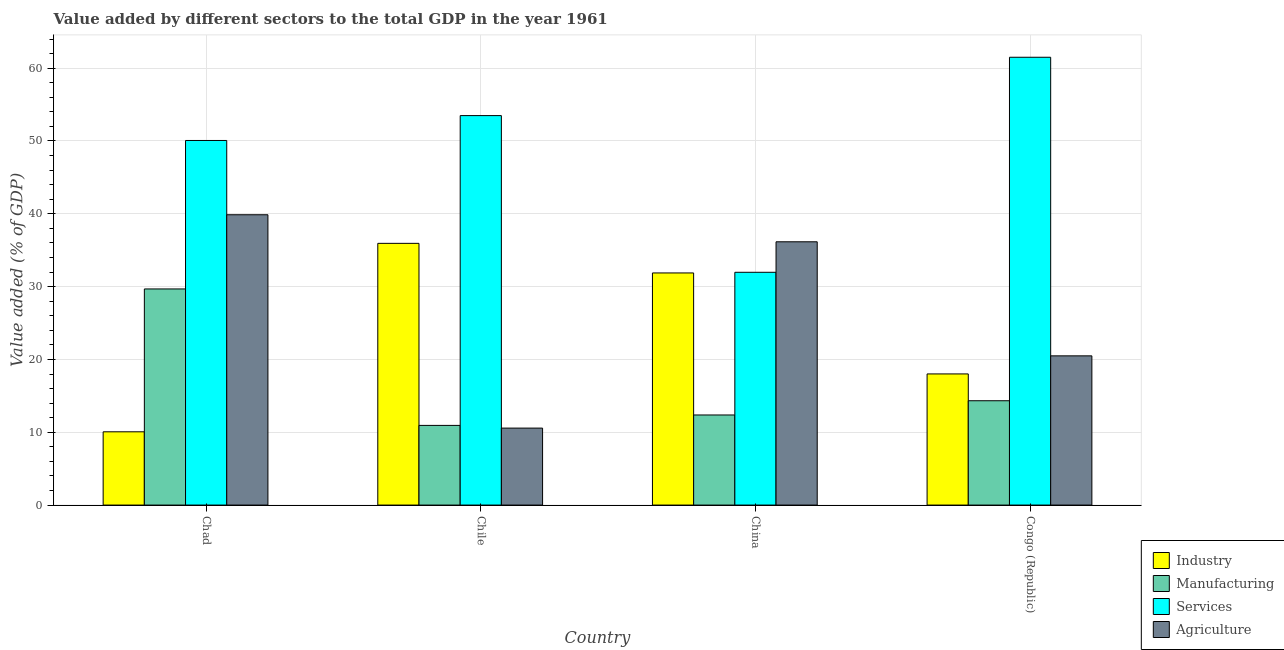How many different coloured bars are there?
Make the answer very short. 4. How many groups of bars are there?
Offer a terse response. 4. Are the number of bars on each tick of the X-axis equal?
Give a very brief answer. Yes. What is the label of the 1st group of bars from the left?
Your response must be concise. Chad. What is the value added by industrial sector in Congo (Republic)?
Ensure brevity in your answer.  18.01. Across all countries, what is the maximum value added by manufacturing sector?
Your answer should be very brief. 29.68. Across all countries, what is the minimum value added by agricultural sector?
Keep it short and to the point. 10.57. In which country was the value added by agricultural sector maximum?
Your answer should be very brief. Chad. In which country was the value added by industrial sector minimum?
Ensure brevity in your answer.  Chad. What is the total value added by industrial sector in the graph?
Your response must be concise. 95.89. What is the difference between the value added by industrial sector in Chile and that in Congo (Republic)?
Keep it short and to the point. 17.93. What is the difference between the value added by industrial sector in China and the value added by agricultural sector in Chad?
Your response must be concise. -7.99. What is the average value added by manufacturing sector per country?
Provide a short and direct response. 16.83. What is the difference between the value added by agricultural sector and value added by manufacturing sector in Congo (Republic)?
Your answer should be compact. 6.16. In how many countries, is the value added by industrial sector greater than 28 %?
Offer a very short reply. 2. What is the ratio of the value added by manufacturing sector in Chile to that in China?
Offer a very short reply. 0.88. Is the value added by services sector in Chad less than that in Congo (Republic)?
Make the answer very short. Yes. What is the difference between the highest and the second highest value added by manufacturing sector?
Provide a succinct answer. 15.35. What is the difference between the highest and the lowest value added by industrial sector?
Give a very brief answer. 25.88. In how many countries, is the value added by industrial sector greater than the average value added by industrial sector taken over all countries?
Offer a very short reply. 2. What does the 2nd bar from the left in China represents?
Your answer should be compact. Manufacturing. What does the 2nd bar from the right in Congo (Republic) represents?
Provide a succinct answer. Services. Is it the case that in every country, the sum of the value added by industrial sector and value added by manufacturing sector is greater than the value added by services sector?
Your answer should be very brief. No. How many bars are there?
Offer a very short reply. 16. Are all the bars in the graph horizontal?
Ensure brevity in your answer.  No. What is the difference between two consecutive major ticks on the Y-axis?
Give a very brief answer. 10. Are the values on the major ticks of Y-axis written in scientific E-notation?
Offer a terse response. No. Does the graph contain grids?
Keep it short and to the point. Yes. Where does the legend appear in the graph?
Your answer should be compact. Bottom right. How many legend labels are there?
Keep it short and to the point. 4. What is the title of the graph?
Provide a short and direct response. Value added by different sectors to the total GDP in the year 1961. What is the label or title of the Y-axis?
Ensure brevity in your answer.  Value added (% of GDP). What is the Value added (% of GDP) in Industry in Chad?
Your response must be concise. 10.06. What is the Value added (% of GDP) of Manufacturing in Chad?
Provide a succinct answer. 29.68. What is the Value added (% of GDP) in Services in Chad?
Give a very brief answer. 50.07. What is the Value added (% of GDP) in Agriculture in Chad?
Keep it short and to the point. 39.87. What is the Value added (% of GDP) of Industry in Chile?
Make the answer very short. 35.94. What is the Value added (% of GDP) in Manufacturing in Chile?
Provide a short and direct response. 10.94. What is the Value added (% of GDP) in Services in Chile?
Provide a short and direct response. 53.49. What is the Value added (% of GDP) in Agriculture in Chile?
Ensure brevity in your answer.  10.57. What is the Value added (% of GDP) in Industry in China?
Ensure brevity in your answer.  31.88. What is the Value added (% of GDP) of Manufacturing in China?
Your response must be concise. 12.37. What is the Value added (% of GDP) of Services in China?
Keep it short and to the point. 31.97. What is the Value added (% of GDP) of Agriculture in China?
Give a very brief answer. 36.16. What is the Value added (% of GDP) in Industry in Congo (Republic)?
Provide a short and direct response. 18.01. What is the Value added (% of GDP) in Manufacturing in Congo (Republic)?
Your answer should be very brief. 14.33. What is the Value added (% of GDP) of Services in Congo (Republic)?
Offer a terse response. 61.5. What is the Value added (% of GDP) in Agriculture in Congo (Republic)?
Provide a succinct answer. 20.49. Across all countries, what is the maximum Value added (% of GDP) of Industry?
Your answer should be very brief. 35.94. Across all countries, what is the maximum Value added (% of GDP) of Manufacturing?
Your answer should be very brief. 29.68. Across all countries, what is the maximum Value added (% of GDP) of Services?
Provide a succinct answer. 61.5. Across all countries, what is the maximum Value added (% of GDP) in Agriculture?
Make the answer very short. 39.87. Across all countries, what is the minimum Value added (% of GDP) in Industry?
Your response must be concise. 10.06. Across all countries, what is the minimum Value added (% of GDP) of Manufacturing?
Offer a very short reply. 10.94. Across all countries, what is the minimum Value added (% of GDP) of Services?
Give a very brief answer. 31.97. Across all countries, what is the minimum Value added (% of GDP) in Agriculture?
Ensure brevity in your answer.  10.57. What is the total Value added (% of GDP) in Industry in the graph?
Provide a short and direct response. 95.89. What is the total Value added (% of GDP) in Manufacturing in the graph?
Provide a succinct answer. 67.32. What is the total Value added (% of GDP) in Services in the graph?
Your answer should be very brief. 197.02. What is the total Value added (% of GDP) of Agriculture in the graph?
Give a very brief answer. 107.09. What is the difference between the Value added (% of GDP) in Industry in Chad and that in Chile?
Make the answer very short. -25.88. What is the difference between the Value added (% of GDP) in Manufacturing in Chad and that in Chile?
Ensure brevity in your answer.  18.74. What is the difference between the Value added (% of GDP) in Services in Chad and that in Chile?
Keep it short and to the point. -3.42. What is the difference between the Value added (% of GDP) in Agriculture in Chad and that in Chile?
Provide a succinct answer. 29.3. What is the difference between the Value added (% of GDP) in Industry in Chad and that in China?
Provide a succinct answer. -21.81. What is the difference between the Value added (% of GDP) of Manufacturing in Chad and that in China?
Your answer should be compact. 17.31. What is the difference between the Value added (% of GDP) of Services in Chad and that in China?
Your answer should be compact. 18.1. What is the difference between the Value added (% of GDP) of Agriculture in Chad and that in China?
Your answer should be very brief. 3.71. What is the difference between the Value added (% of GDP) of Industry in Chad and that in Congo (Republic)?
Your answer should be very brief. -7.95. What is the difference between the Value added (% of GDP) in Manufacturing in Chad and that in Congo (Republic)?
Ensure brevity in your answer.  15.35. What is the difference between the Value added (% of GDP) in Services in Chad and that in Congo (Republic)?
Provide a short and direct response. -11.43. What is the difference between the Value added (% of GDP) of Agriculture in Chad and that in Congo (Republic)?
Offer a very short reply. 19.38. What is the difference between the Value added (% of GDP) of Industry in Chile and that in China?
Give a very brief answer. 4.07. What is the difference between the Value added (% of GDP) of Manufacturing in Chile and that in China?
Your response must be concise. -1.43. What is the difference between the Value added (% of GDP) of Services in Chile and that in China?
Keep it short and to the point. 21.52. What is the difference between the Value added (% of GDP) of Agriculture in Chile and that in China?
Ensure brevity in your answer.  -25.58. What is the difference between the Value added (% of GDP) in Industry in Chile and that in Congo (Republic)?
Your response must be concise. 17.93. What is the difference between the Value added (% of GDP) of Manufacturing in Chile and that in Congo (Republic)?
Your response must be concise. -3.39. What is the difference between the Value added (% of GDP) in Services in Chile and that in Congo (Republic)?
Provide a succinct answer. -8.01. What is the difference between the Value added (% of GDP) in Agriculture in Chile and that in Congo (Republic)?
Offer a terse response. -9.92. What is the difference between the Value added (% of GDP) of Industry in China and that in Congo (Republic)?
Offer a very short reply. 13.87. What is the difference between the Value added (% of GDP) in Manufacturing in China and that in Congo (Republic)?
Keep it short and to the point. -1.96. What is the difference between the Value added (% of GDP) in Services in China and that in Congo (Republic)?
Offer a very short reply. -29.53. What is the difference between the Value added (% of GDP) of Agriculture in China and that in Congo (Republic)?
Give a very brief answer. 15.66. What is the difference between the Value added (% of GDP) in Industry in Chad and the Value added (% of GDP) in Manufacturing in Chile?
Offer a very short reply. -0.88. What is the difference between the Value added (% of GDP) in Industry in Chad and the Value added (% of GDP) in Services in Chile?
Offer a very short reply. -43.42. What is the difference between the Value added (% of GDP) of Industry in Chad and the Value added (% of GDP) of Agriculture in Chile?
Keep it short and to the point. -0.51. What is the difference between the Value added (% of GDP) of Manufacturing in Chad and the Value added (% of GDP) of Services in Chile?
Offer a terse response. -23.81. What is the difference between the Value added (% of GDP) in Manufacturing in Chad and the Value added (% of GDP) in Agriculture in Chile?
Your answer should be compact. 19.11. What is the difference between the Value added (% of GDP) of Services in Chad and the Value added (% of GDP) of Agriculture in Chile?
Provide a succinct answer. 39.5. What is the difference between the Value added (% of GDP) of Industry in Chad and the Value added (% of GDP) of Manufacturing in China?
Your answer should be very brief. -2.31. What is the difference between the Value added (% of GDP) of Industry in Chad and the Value added (% of GDP) of Services in China?
Ensure brevity in your answer.  -21.9. What is the difference between the Value added (% of GDP) of Industry in Chad and the Value added (% of GDP) of Agriculture in China?
Keep it short and to the point. -26.09. What is the difference between the Value added (% of GDP) in Manufacturing in Chad and the Value added (% of GDP) in Services in China?
Make the answer very short. -2.29. What is the difference between the Value added (% of GDP) in Manufacturing in Chad and the Value added (% of GDP) in Agriculture in China?
Keep it short and to the point. -6.48. What is the difference between the Value added (% of GDP) in Services in Chad and the Value added (% of GDP) in Agriculture in China?
Offer a terse response. 13.91. What is the difference between the Value added (% of GDP) in Industry in Chad and the Value added (% of GDP) in Manufacturing in Congo (Republic)?
Offer a terse response. -4.27. What is the difference between the Value added (% of GDP) of Industry in Chad and the Value added (% of GDP) of Services in Congo (Republic)?
Ensure brevity in your answer.  -51.44. What is the difference between the Value added (% of GDP) in Industry in Chad and the Value added (% of GDP) in Agriculture in Congo (Republic)?
Keep it short and to the point. -10.43. What is the difference between the Value added (% of GDP) in Manufacturing in Chad and the Value added (% of GDP) in Services in Congo (Republic)?
Your answer should be very brief. -31.82. What is the difference between the Value added (% of GDP) of Manufacturing in Chad and the Value added (% of GDP) of Agriculture in Congo (Republic)?
Offer a terse response. 9.19. What is the difference between the Value added (% of GDP) in Services in Chad and the Value added (% of GDP) in Agriculture in Congo (Republic)?
Make the answer very short. 29.58. What is the difference between the Value added (% of GDP) in Industry in Chile and the Value added (% of GDP) in Manufacturing in China?
Ensure brevity in your answer.  23.57. What is the difference between the Value added (% of GDP) in Industry in Chile and the Value added (% of GDP) in Services in China?
Your answer should be compact. 3.98. What is the difference between the Value added (% of GDP) in Industry in Chile and the Value added (% of GDP) in Agriculture in China?
Make the answer very short. -0.21. What is the difference between the Value added (% of GDP) in Manufacturing in Chile and the Value added (% of GDP) in Services in China?
Make the answer very short. -21.03. What is the difference between the Value added (% of GDP) of Manufacturing in Chile and the Value added (% of GDP) of Agriculture in China?
Offer a terse response. -25.21. What is the difference between the Value added (% of GDP) in Services in Chile and the Value added (% of GDP) in Agriculture in China?
Ensure brevity in your answer.  17.33. What is the difference between the Value added (% of GDP) of Industry in Chile and the Value added (% of GDP) of Manufacturing in Congo (Republic)?
Ensure brevity in your answer.  21.62. What is the difference between the Value added (% of GDP) in Industry in Chile and the Value added (% of GDP) in Services in Congo (Republic)?
Offer a terse response. -25.55. What is the difference between the Value added (% of GDP) of Industry in Chile and the Value added (% of GDP) of Agriculture in Congo (Republic)?
Your response must be concise. 15.45. What is the difference between the Value added (% of GDP) in Manufacturing in Chile and the Value added (% of GDP) in Services in Congo (Republic)?
Provide a succinct answer. -50.56. What is the difference between the Value added (% of GDP) in Manufacturing in Chile and the Value added (% of GDP) in Agriculture in Congo (Republic)?
Your response must be concise. -9.55. What is the difference between the Value added (% of GDP) in Services in Chile and the Value added (% of GDP) in Agriculture in Congo (Republic)?
Ensure brevity in your answer.  32.99. What is the difference between the Value added (% of GDP) in Industry in China and the Value added (% of GDP) in Manufacturing in Congo (Republic)?
Your answer should be very brief. 17.55. What is the difference between the Value added (% of GDP) of Industry in China and the Value added (% of GDP) of Services in Congo (Republic)?
Your answer should be compact. -29.62. What is the difference between the Value added (% of GDP) in Industry in China and the Value added (% of GDP) in Agriculture in Congo (Republic)?
Provide a succinct answer. 11.39. What is the difference between the Value added (% of GDP) in Manufacturing in China and the Value added (% of GDP) in Services in Congo (Republic)?
Provide a succinct answer. -49.12. What is the difference between the Value added (% of GDP) in Manufacturing in China and the Value added (% of GDP) in Agriculture in Congo (Republic)?
Ensure brevity in your answer.  -8.12. What is the difference between the Value added (% of GDP) of Services in China and the Value added (% of GDP) of Agriculture in Congo (Republic)?
Your answer should be compact. 11.48. What is the average Value added (% of GDP) of Industry per country?
Keep it short and to the point. 23.97. What is the average Value added (% of GDP) of Manufacturing per country?
Keep it short and to the point. 16.83. What is the average Value added (% of GDP) in Services per country?
Offer a terse response. 49.25. What is the average Value added (% of GDP) in Agriculture per country?
Your answer should be very brief. 26.77. What is the difference between the Value added (% of GDP) in Industry and Value added (% of GDP) in Manufacturing in Chad?
Offer a very short reply. -19.62. What is the difference between the Value added (% of GDP) in Industry and Value added (% of GDP) in Services in Chad?
Make the answer very short. -40.01. What is the difference between the Value added (% of GDP) of Industry and Value added (% of GDP) of Agriculture in Chad?
Offer a very short reply. -29.81. What is the difference between the Value added (% of GDP) of Manufacturing and Value added (% of GDP) of Services in Chad?
Keep it short and to the point. -20.39. What is the difference between the Value added (% of GDP) of Manufacturing and Value added (% of GDP) of Agriculture in Chad?
Provide a short and direct response. -10.19. What is the difference between the Value added (% of GDP) of Services and Value added (% of GDP) of Agriculture in Chad?
Make the answer very short. 10.2. What is the difference between the Value added (% of GDP) in Industry and Value added (% of GDP) in Manufacturing in Chile?
Your response must be concise. 25. What is the difference between the Value added (% of GDP) of Industry and Value added (% of GDP) of Services in Chile?
Your answer should be compact. -17.54. What is the difference between the Value added (% of GDP) of Industry and Value added (% of GDP) of Agriculture in Chile?
Offer a terse response. 25.37. What is the difference between the Value added (% of GDP) in Manufacturing and Value added (% of GDP) in Services in Chile?
Your answer should be compact. -42.54. What is the difference between the Value added (% of GDP) in Manufacturing and Value added (% of GDP) in Agriculture in Chile?
Provide a short and direct response. 0.37. What is the difference between the Value added (% of GDP) of Services and Value added (% of GDP) of Agriculture in Chile?
Provide a short and direct response. 42.91. What is the difference between the Value added (% of GDP) in Industry and Value added (% of GDP) in Manufacturing in China?
Give a very brief answer. 19.5. What is the difference between the Value added (% of GDP) in Industry and Value added (% of GDP) in Services in China?
Give a very brief answer. -0.09. What is the difference between the Value added (% of GDP) of Industry and Value added (% of GDP) of Agriculture in China?
Provide a succinct answer. -4.28. What is the difference between the Value added (% of GDP) in Manufacturing and Value added (% of GDP) in Services in China?
Offer a very short reply. -19.59. What is the difference between the Value added (% of GDP) of Manufacturing and Value added (% of GDP) of Agriculture in China?
Keep it short and to the point. -23.78. What is the difference between the Value added (% of GDP) in Services and Value added (% of GDP) in Agriculture in China?
Make the answer very short. -4.19. What is the difference between the Value added (% of GDP) of Industry and Value added (% of GDP) of Manufacturing in Congo (Republic)?
Your response must be concise. 3.68. What is the difference between the Value added (% of GDP) in Industry and Value added (% of GDP) in Services in Congo (Republic)?
Offer a terse response. -43.49. What is the difference between the Value added (% of GDP) in Industry and Value added (% of GDP) in Agriculture in Congo (Republic)?
Your response must be concise. -2.48. What is the difference between the Value added (% of GDP) in Manufacturing and Value added (% of GDP) in Services in Congo (Republic)?
Ensure brevity in your answer.  -47.17. What is the difference between the Value added (% of GDP) in Manufacturing and Value added (% of GDP) in Agriculture in Congo (Republic)?
Your response must be concise. -6.16. What is the difference between the Value added (% of GDP) in Services and Value added (% of GDP) in Agriculture in Congo (Republic)?
Ensure brevity in your answer.  41.01. What is the ratio of the Value added (% of GDP) in Industry in Chad to that in Chile?
Your answer should be very brief. 0.28. What is the ratio of the Value added (% of GDP) in Manufacturing in Chad to that in Chile?
Provide a short and direct response. 2.71. What is the ratio of the Value added (% of GDP) of Services in Chad to that in Chile?
Your response must be concise. 0.94. What is the ratio of the Value added (% of GDP) of Agriculture in Chad to that in Chile?
Offer a terse response. 3.77. What is the ratio of the Value added (% of GDP) of Industry in Chad to that in China?
Provide a short and direct response. 0.32. What is the ratio of the Value added (% of GDP) in Manufacturing in Chad to that in China?
Your answer should be very brief. 2.4. What is the ratio of the Value added (% of GDP) in Services in Chad to that in China?
Keep it short and to the point. 1.57. What is the ratio of the Value added (% of GDP) of Agriculture in Chad to that in China?
Ensure brevity in your answer.  1.1. What is the ratio of the Value added (% of GDP) of Industry in Chad to that in Congo (Republic)?
Offer a terse response. 0.56. What is the ratio of the Value added (% of GDP) of Manufacturing in Chad to that in Congo (Republic)?
Keep it short and to the point. 2.07. What is the ratio of the Value added (% of GDP) of Services in Chad to that in Congo (Republic)?
Your response must be concise. 0.81. What is the ratio of the Value added (% of GDP) in Agriculture in Chad to that in Congo (Republic)?
Offer a very short reply. 1.95. What is the ratio of the Value added (% of GDP) in Industry in Chile to that in China?
Your answer should be very brief. 1.13. What is the ratio of the Value added (% of GDP) of Manufacturing in Chile to that in China?
Your answer should be very brief. 0.88. What is the ratio of the Value added (% of GDP) in Services in Chile to that in China?
Provide a succinct answer. 1.67. What is the ratio of the Value added (% of GDP) in Agriculture in Chile to that in China?
Ensure brevity in your answer.  0.29. What is the ratio of the Value added (% of GDP) in Industry in Chile to that in Congo (Republic)?
Keep it short and to the point. 2. What is the ratio of the Value added (% of GDP) in Manufacturing in Chile to that in Congo (Republic)?
Your answer should be compact. 0.76. What is the ratio of the Value added (% of GDP) of Services in Chile to that in Congo (Republic)?
Offer a terse response. 0.87. What is the ratio of the Value added (% of GDP) of Agriculture in Chile to that in Congo (Republic)?
Ensure brevity in your answer.  0.52. What is the ratio of the Value added (% of GDP) of Industry in China to that in Congo (Republic)?
Make the answer very short. 1.77. What is the ratio of the Value added (% of GDP) of Manufacturing in China to that in Congo (Republic)?
Make the answer very short. 0.86. What is the ratio of the Value added (% of GDP) in Services in China to that in Congo (Republic)?
Your answer should be very brief. 0.52. What is the ratio of the Value added (% of GDP) in Agriculture in China to that in Congo (Republic)?
Your answer should be compact. 1.76. What is the difference between the highest and the second highest Value added (% of GDP) in Industry?
Provide a short and direct response. 4.07. What is the difference between the highest and the second highest Value added (% of GDP) of Manufacturing?
Give a very brief answer. 15.35. What is the difference between the highest and the second highest Value added (% of GDP) in Services?
Ensure brevity in your answer.  8.01. What is the difference between the highest and the second highest Value added (% of GDP) in Agriculture?
Give a very brief answer. 3.71. What is the difference between the highest and the lowest Value added (% of GDP) of Industry?
Your answer should be compact. 25.88. What is the difference between the highest and the lowest Value added (% of GDP) of Manufacturing?
Your response must be concise. 18.74. What is the difference between the highest and the lowest Value added (% of GDP) of Services?
Your answer should be compact. 29.53. What is the difference between the highest and the lowest Value added (% of GDP) in Agriculture?
Provide a succinct answer. 29.3. 